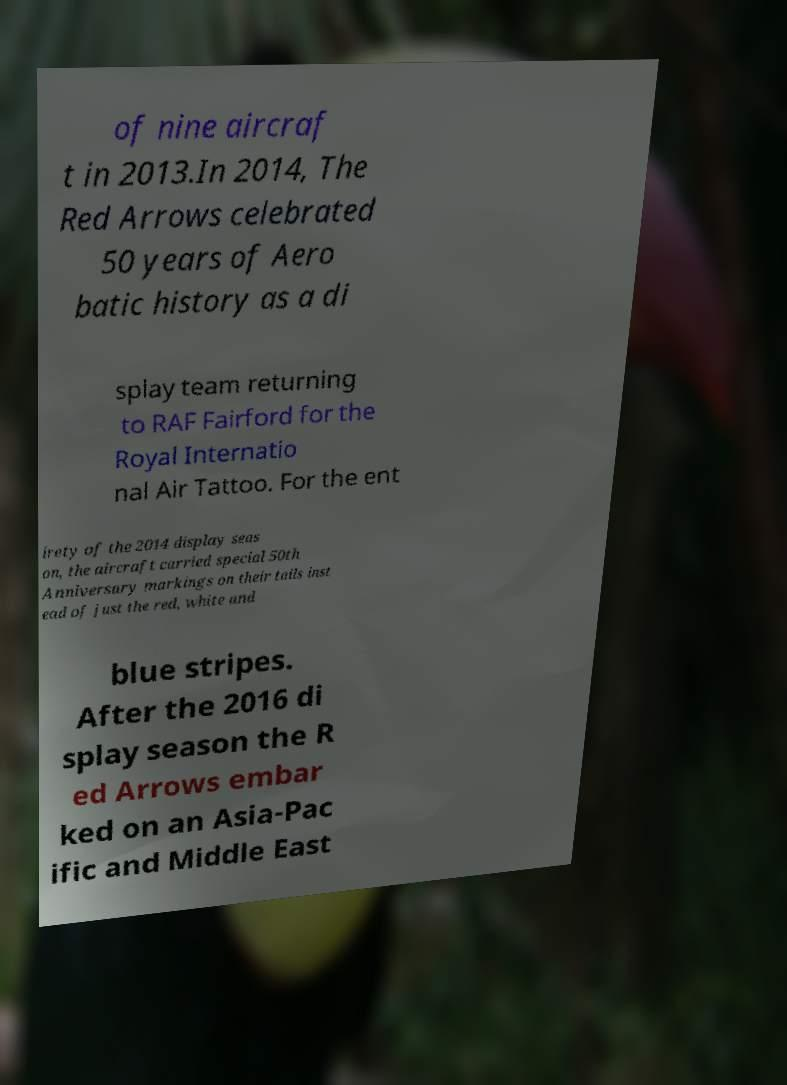Could you assist in decoding the text presented in this image and type it out clearly? of nine aircraf t in 2013.In 2014, The Red Arrows celebrated 50 years of Aero batic history as a di splay team returning to RAF Fairford for the Royal Internatio nal Air Tattoo. For the ent irety of the 2014 display seas on, the aircraft carried special 50th Anniversary markings on their tails inst ead of just the red, white and blue stripes. After the 2016 di splay season the R ed Arrows embar ked on an Asia-Pac ific and Middle East 